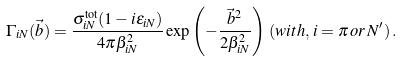Convert formula to latex. <formula><loc_0><loc_0><loc_500><loc_500>\Gamma _ { i N } ( \vec { b } ) = \frac { \sigma ^ { \text {tot} } _ { i N } ( 1 - i \epsilon _ { i N } ) } { 4 \pi \beta _ { i N } ^ { 2 } } \exp \left ( { - \frac { \vec { b } ^ { 2 } } { 2 \beta _ { i N } ^ { 2 } } } \right ) \, ( w i t h , \, i = \pi \, o r \, N ^ { \prime } ) \, .</formula> 